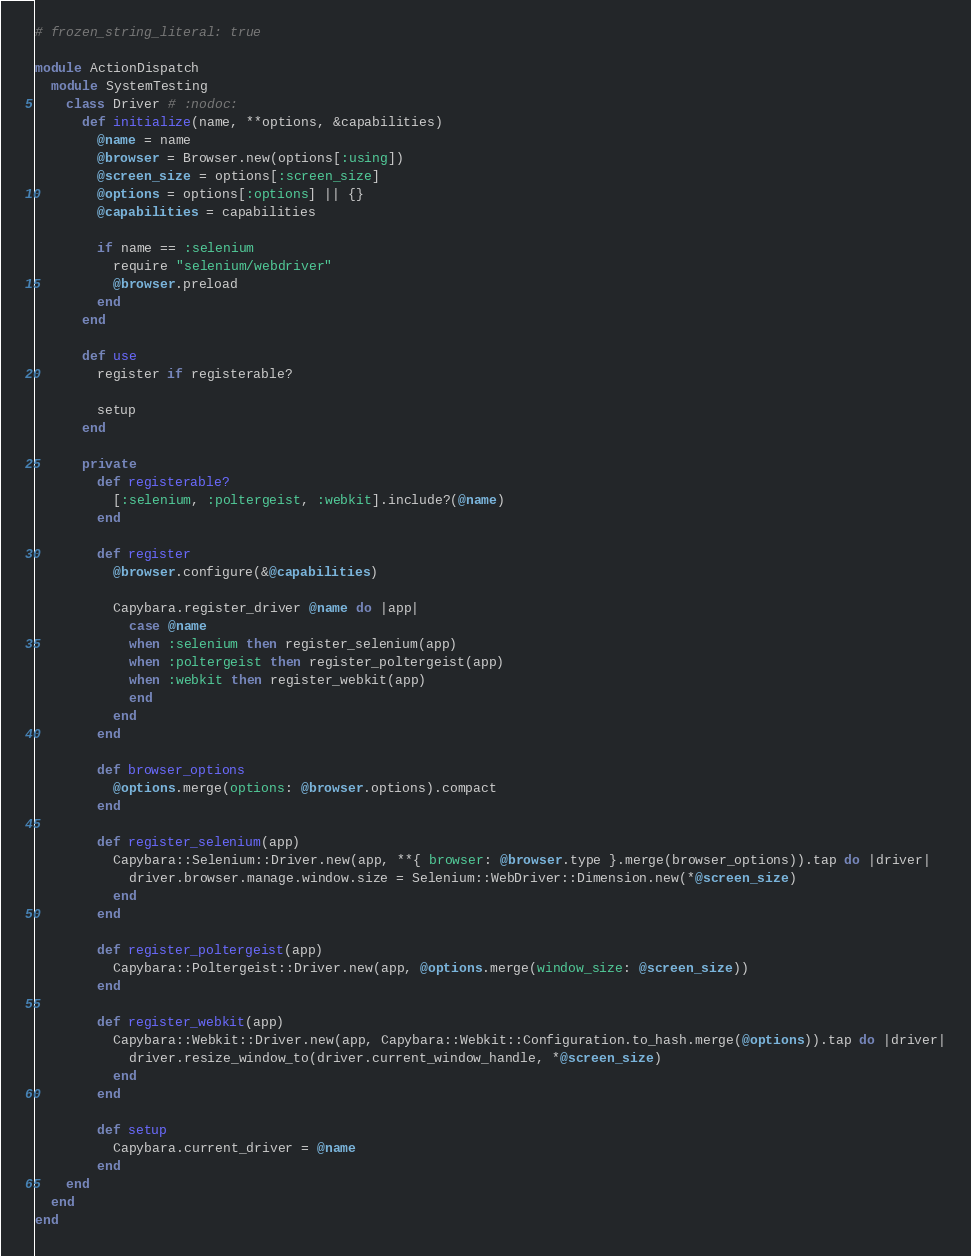Convert code to text. <code><loc_0><loc_0><loc_500><loc_500><_Ruby_># frozen_string_literal: true

module ActionDispatch
  module SystemTesting
    class Driver # :nodoc:
      def initialize(name, **options, &capabilities)
        @name = name
        @browser = Browser.new(options[:using])
        @screen_size = options[:screen_size]
        @options = options[:options] || {}
        @capabilities = capabilities

        if name == :selenium
          require "selenium/webdriver"
          @browser.preload
        end
      end

      def use
        register if registerable?

        setup
      end

      private
        def registerable?
          [:selenium, :poltergeist, :webkit].include?(@name)
        end

        def register
          @browser.configure(&@capabilities)

          Capybara.register_driver @name do |app|
            case @name
            when :selenium then register_selenium(app)
            when :poltergeist then register_poltergeist(app)
            when :webkit then register_webkit(app)
            end
          end
        end

        def browser_options
          @options.merge(options: @browser.options).compact
        end

        def register_selenium(app)
          Capybara::Selenium::Driver.new(app, **{ browser: @browser.type }.merge(browser_options)).tap do |driver|
            driver.browser.manage.window.size = Selenium::WebDriver::Dimension.new(*@screen_size)
          end
        end

        def register_poltergeist(app)
          Capybara::Poltergeist::Driver.new(app, @options.merge(window_size: @screen_size))
        end

        def register_webkit(app)
          Capybara::Webkit::Driver.new(app, Capybara::Webkit::Configuration.to_hash.merge(@options)).tap do |driver|
            driver.resize_window_to(driver.current_window_handle, *@screen_size)
          end
        end

        def setup
          Capybara.current_driver = @name
        end
    end
  end
end
</code> 